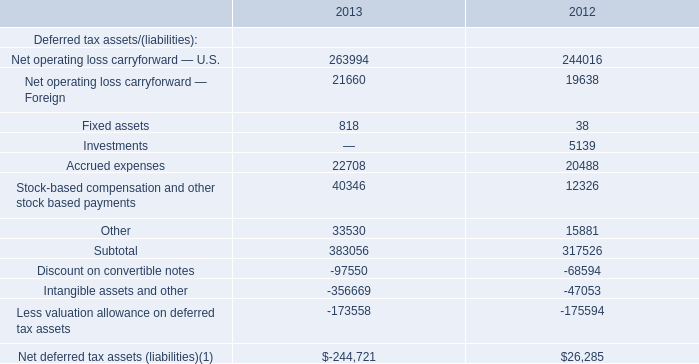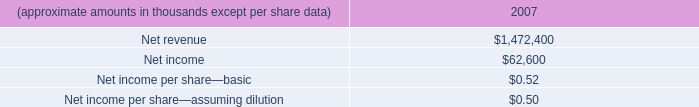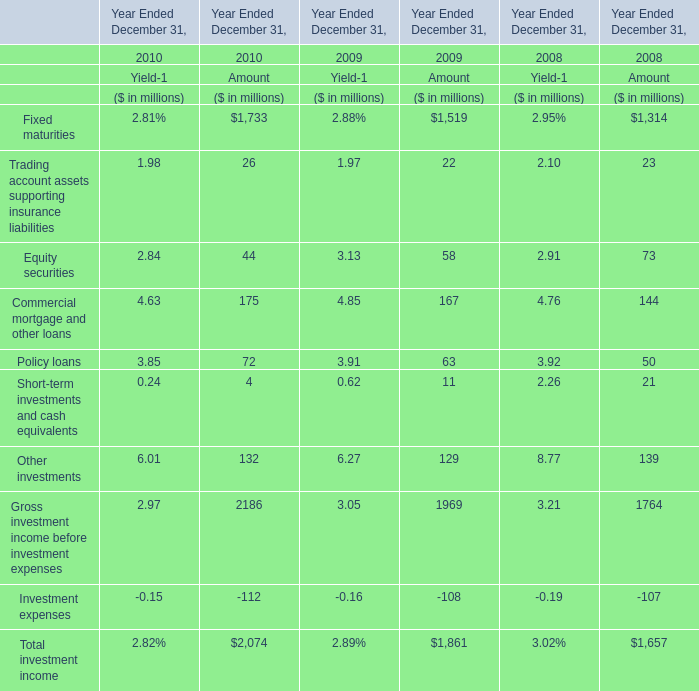Which year Ended December 31 is the Amount of Equity securities the highest? 
Answer: 2008. 